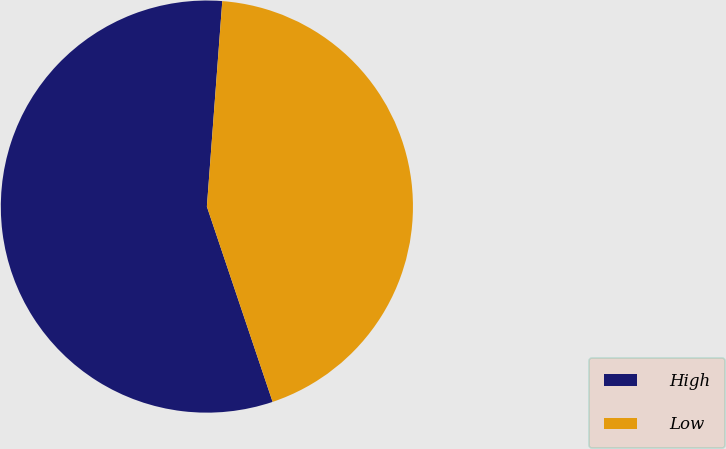<chart> <loc_0><loc_0><loc_500><loc_500><pie_chart><fcel>High<fcel>Low<nl><fcel>56.36%<fcel>43.64%<nl></chart> 